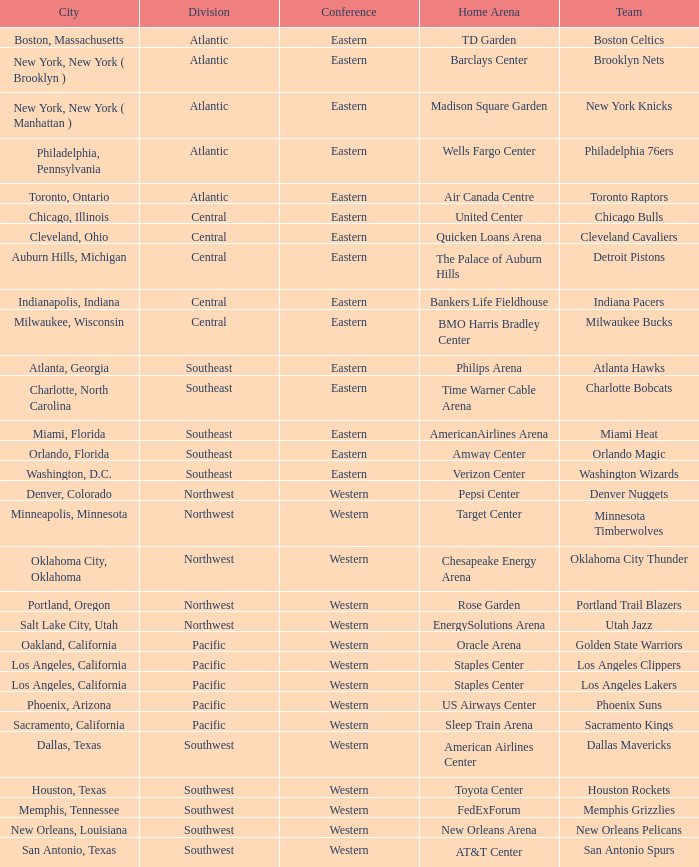Which city includes the Target Center arena? Minneapolis, Minnesota. Write the full table. {'header': ['City', 'Division', 'Conference', 'Home Arena', 'Team'], 'rows': [['Boston, Massachusetts', 'Atlantic', 'Eastern', 'TD Garden', 'Boston Celtics'], ['New York, New York ( Brooklyn )', 'Atlantic', 'Eastern', 'Barclays Center', 'Brooklyn Nets'], ['New York, New York ( Manhattan )', 'Atlantic', 'Eastern', 'Madison Square Garden', 'New York Knicks'], ['Philadelphia, Pennsylvania', 'Atlantic', 'Eastern', 'Wells Fargo Center', 'Philadelphia 76ers'], ['Toronto, Ontario', 'Atlantic', 'Eastern', 'Air Canada Centre', 'Toronto Raptors'], ['Chicago, Illinois', 'Central', 'Eastern', 'United Center', 'Chicago Bulls'], ['Cleveland, Ohio', 'Central', 'Eastern', 'Quicken Loans Arena', 'Cleveland Cavaliers'], ['Auburn Hills, Michigan', 'Central', 'Eastern', 'The Palace of Auburn Hills', 'Detroit Pistons'], ['Indianapolis, Indiana', 'Central', 'Eastern', 'Bankers Life Fieldhouse', 'Indiana Pacers'], ['Milwaukee, Wisconsin', 'Central', 'Eastern', 'BMO Harris Bradley Center', 'Milwaukee Bucks'], ['Atlanta, Georgia', 'Southeast', 'Eastern', 'Philips Arena', 'Atlanta Hawks'], ['Charlotte, North Carolina', 'Southeast', 'Eastern', 'Time Warner Cable Arena', 'Charlotte Bobcats'], ['Miami, Florida', 'Southeast', 'Eastern', 'AmericanAirlines Arena', 'Miami Heat'], ['Orlando, Florida', 'Southeast', 'Eastern', 'Amway Center', 'Orlando Magic'], ['Washington, D.C.', 'Southeast', 'Eastern', 'Verizon Center', 'Washington Wizards'], ['Denver, Colorado', 'Northwest', 'Western', 'Pepsi Center', 'Denver Nuggets'], ['Minneapolis, Minnesota', 'Northwest', 'Western', 'Target Center', 'Minnesota Timberwolves'], ['Oklahoma City, Oklahoma', 'Northwest', 'Western', 'Chesapeake Energy Arena', 'Oklahoma City Thunder'], ['Portland, Oregon', 'Northwest', 'Western', 'Rose Garden', 'Portland Trail Blazers'], ['Salt Lake City, Utah', 'Northwest', 'Western', 'EnergySolutions Arena', 'Utah Jazz'], ['Oakland, California', 'Pacific', 'Western', 'Oracle Arena', 'Golden State Warriors'], ['Los Angeles, California', 'Pacific', 'Western', 'Staples Center', 'Los Angeles Clippers'], ['Los Angeles, California', 'Pacific', 'Western', 'Staples Center', 'Los Angeles Lakers'], ['Phoenix, Arizona', 'Pacific', 'Western', 'US Airways Center', 'Phoenix Suns'], ['Sacramento, California', 'Pacific', 'Western', 'Sleep Train Arena', 'Sacramento Kings'], ['Dallas, Texas', 'Southwest', 'Western', 'American Airlines Center', 'Dallas Mavericks'], ['Houston, Texas', 'Southwest', 'Western', 'Toyota Center', 'Houston Rockets'], ['Memphis, Tennessee', 'Southwest', 'Western', 'FedExForum', 'Memphis Grizzlies'], ['New Orleans, Louisiana', 'Southwest', 'Western', 'New Orleans Arena', 'New Orleans Pelicans'], ['San Antonio, Texas', 'Southwest', 'Western', 'AT&T Center', 'San Antonio Spurs']]} 